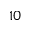Convert formula to latex. <formula><loc_0><loc_0><loc_500><loc_500>1 0</formula> 